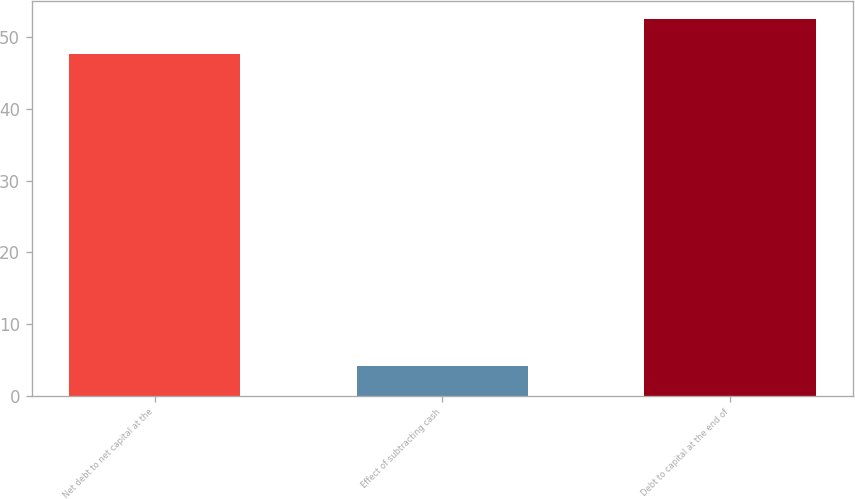<chart> <loc_0><loc_0><loc_500><loc_500><bar_chart><fcel>Net debt to net capital at the<fcel>Effect of subtracting cash<fcel>Debt to capital at the end of<nl><fcel>47.7<fcel>4.1<fcel>52.47<nl></chart> 